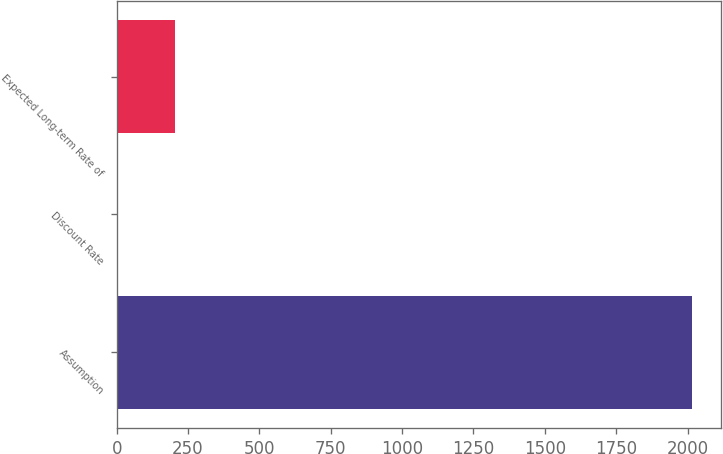<chart> <loc_0><loc_0><loc_500><loc_500><bar_chart><fcel>Assumption<fcel>Discount Rate<fcel>Expected Long-term Rate of<nl><fcel>2015<fcel>4.3<fcel>205.37<nl></chart> 